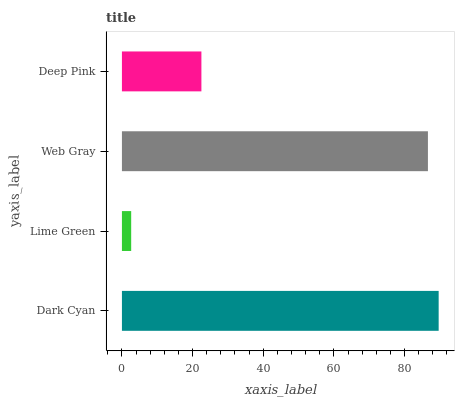Is Lime Green the minimum?
Answer yes or no. Yes. Is Dark Cyan the maximum?
Answer yes or no. Yes. Is Web Gray the minimum?
Answer yes or no. No. Is Web Gray the maximum?
Answer yes or no. No. Is Web Gray greater than Lime Green?
Answer yes or no. Yes. Is Lime Green less than Web Gray?
Answer yes or no. Yes. Is Lime Green greater than Web Gray?
Answer yes or no. No. Is Web Gray less than Lime Green?
Answer yes or no. No. Is Web Gray the high median?
Answer yes or no. Yes. Is Deep Pink the low median?
Answer yes or no. Yes. Is Lime Green the high median?
Answer yes or no. No. Is Dark Cyan the low median?
Answer yes or no. No. 